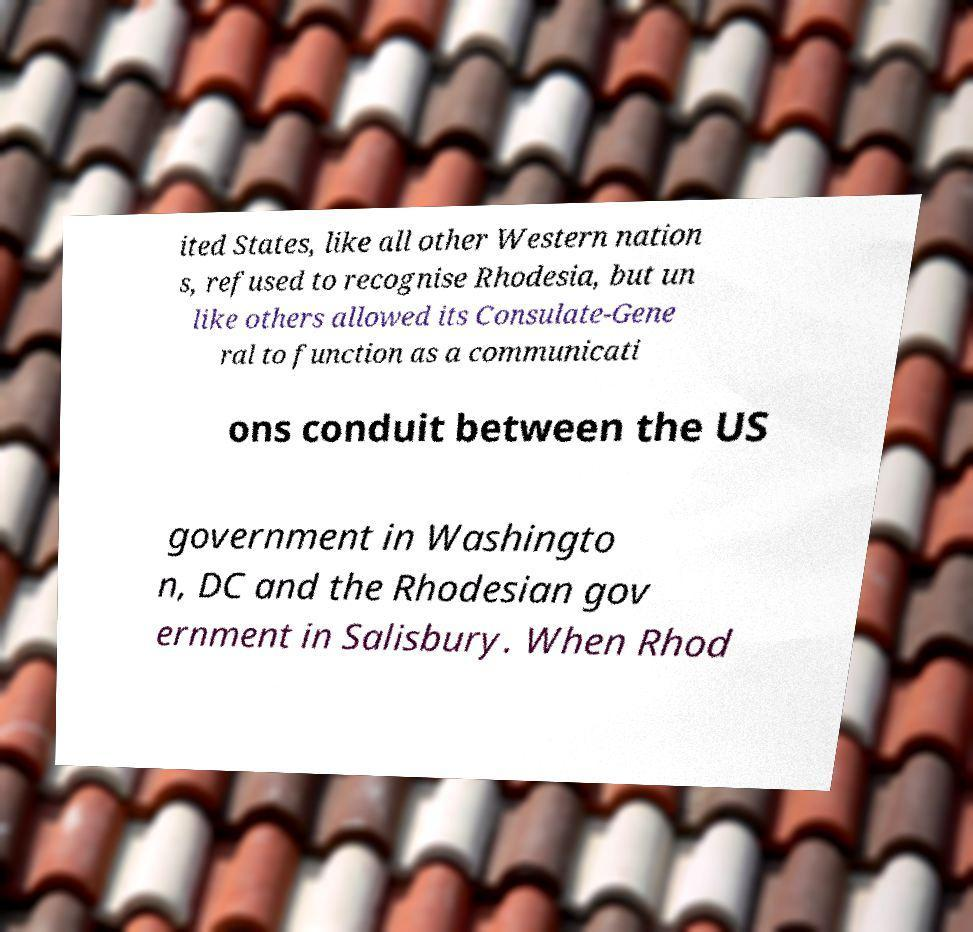Please identify and transcribe the text found in this image. ited States, like all other Western nation s, refused to recognise Rhodesia, but un like others allowed its Consulate-Gene ral to function as a communicati ons conduit between the US government in Washingto n, DC and the Rhodesian gov ernment in Salisbury. When Rhod 